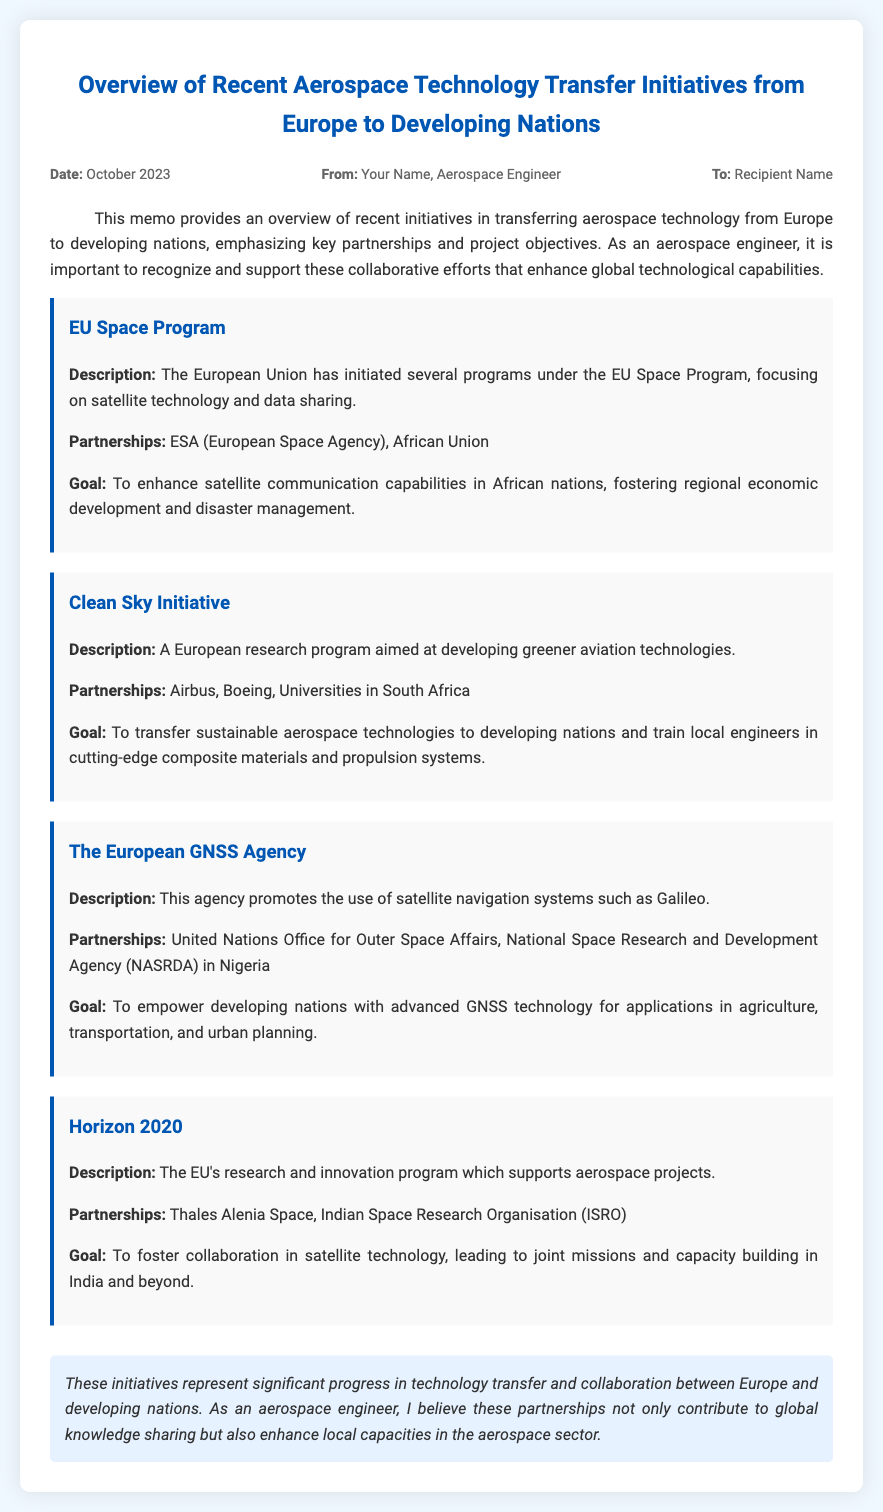What is the date of the memo? The date of the memo is specified in the header of the document.
Answer: October 2023 Who authored the memo? The author of the memo is indicated in the meta section.
Answer: Your Name What is the goal of the EU Space Program? The goal is stated in the EU Space Program initiative section.
Answer: To enhance satellite communication capabilities in African nations Which organizations are partners in the Clean Sky Initiative? The partnerships for the Clean Sky Initiative are listed in that specific initiative section.
Answer: Airbus, Boeing, Universities in South Africa What is the focus of Horizon 2020? The focus of Horizon 2020 is described in its initiative section.
Answer: Research and innovation program which supports aerospace projects How does the European GNSS Agency aim to empower developing nations? The use of advanced GNSS technology for applications is mentioned in the goal of the European GNSS Agency.
Answer: For applications in agriculture, transportation, and urban planning What sector is enhanced through the discussed technology transfer initiatives? The sector enhanced through these initiatives is mentioned in the conclusion of the document.
Answer: Aerospace sector Which program aims to train local engineers? The initiative that mentions training local engineers is outlined in the Clean Sky Initiative section.
Answer: Clean Sky Initiative 